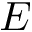<formula> <loc_0><loc_0><loc_500><loc_500>E</formula> 